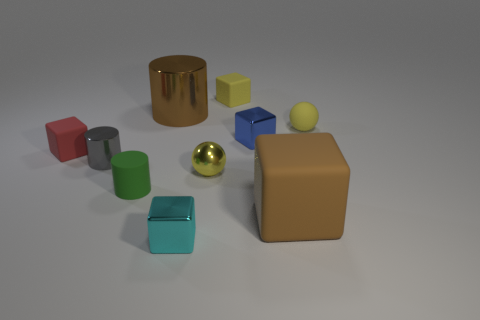Is there any other thing that has the same material as the cyan cube?
Make the answer very short. Yes. What number of tiny objects are either cylinders or green objects?
Offer a terse response. 2. How many objects are either metallic things behind the small blue cube or large red metal blocks?
Make the answer very short. 1. Do the rubber cylinder and the small metallic cylinder have the same color?
Offer a terse response. No. What number of other things are the same shape as the tiny gray metallic object?
Your response must be concise. 2. How many gray things are either tiny metal cubes or tiny shiny objects?
Your answer should be compact. 1. What is the color of the big thing that is the same material as the tiny gray cylinder?
Provide a succinct answer. Brown. Are the tiny yellow sphere on the left side of the blue metallic thing and the big brown thing that is in front of the red matte cube made of the same material?
Provide a succinct answer. No. There is a rubber block that is the same color as the big metal cylinder; what is its size?
Ensure brevity in your answer.  Large. What is the small sphere that is in front of the gray cylinder made of?
Offer a terse response. Metal. 